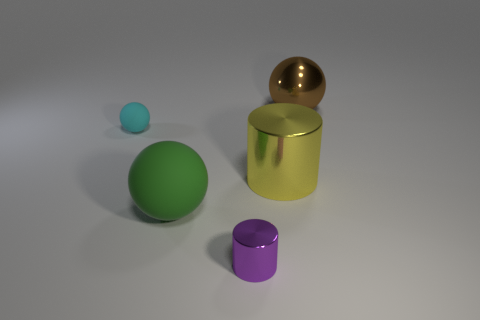Does the big object that is to the left of the yellow metallic cylinder have the same material as the small object that is in front of the large green thing?
Ensure brevity in your answer.  No. What material is the object that is both in front of the small cyan matte object and to the right of the small purple cylinder?
Ensure brevity in your answer.  Metal. There is a tiny purple metal thing; is its shape the same as the large metallic object that is in front of the cyan matte thing?
Offer a very short reply. Yes. There is a small object that is to the right of the rubber object that is in front of the big metallic object that is left of the metallic ball; what is its material?
Provide a short and direct response. Metal. How many other objects are the same size as the yellow thing?
Provide a short and direct response. 2. There is a ball that is to the right of the shiny cylinder to the right of the purple metallic cylinder; how many shiny objects are in front of it?
Make the answer very short. 2. There is a small thing in front of the object to the left of the big green ball; what is it made of?
Keep it short and to the point. Metal. Is there a yellow shiny object that has the same shape as the big brown object?
Offer a very short reply. No. The cylinder that is the same size as the cyan rubber object is what color?
Keep it short and to the point. Purple. What number of objects are spheres that are behind the yellow metal cylinder or metal cylinders behind the tiny shiny object?
Your response must be concise. 3. 